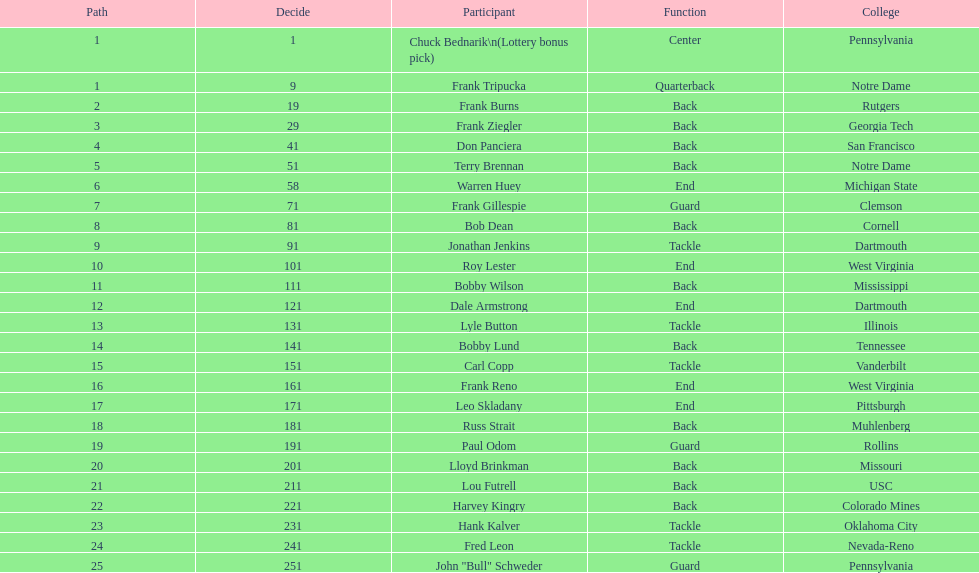How many draft picks were between frank tripucka and dale armstrong? 10. 